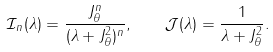Convert formula to latex. <formula><loc_0><loc_0><loc_500><loc_500>\mathcal { I } _ { n } ( \lambda ) = \frac { J _ { \theta } ^ { n } } { ( \lambda + J _ { \theta } ^ { 2 } ) ^ { n } } , \quad \mathcal { J } ( \lambda ) = \frac { 1 } { \lambda + J _ { \theta } ^ { 2 } } .</formula> 